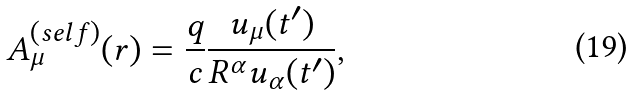Convert formula to latex. <formula><loc_0><loc_0><loc_500><loc_500>A _ { \mu } ^ { ( s e l f ) } ( r ) = \frac { q } { c } \frac { u _ { \mu } ( t ^ { \prime } ) } { R ^ { \alpha } u _ { \alpha } ( t ^ { \prime } ) } ,</formula> 